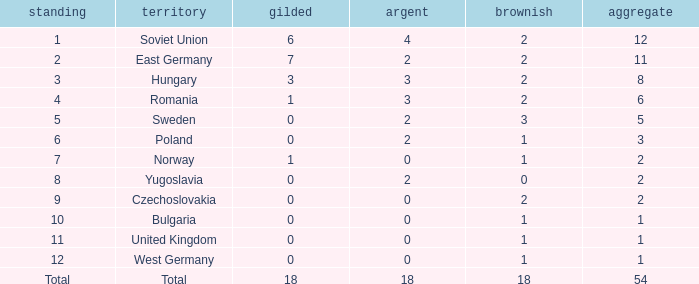What's the total of rank number 6 with more than 2 silver? None. 